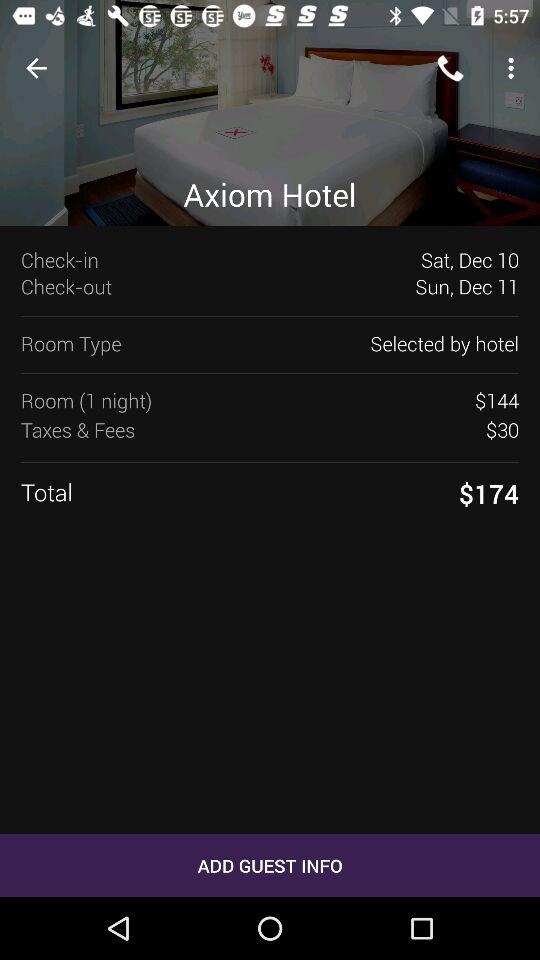How many days is the reservation for?
Answer the question using a single word or phrase. 1 